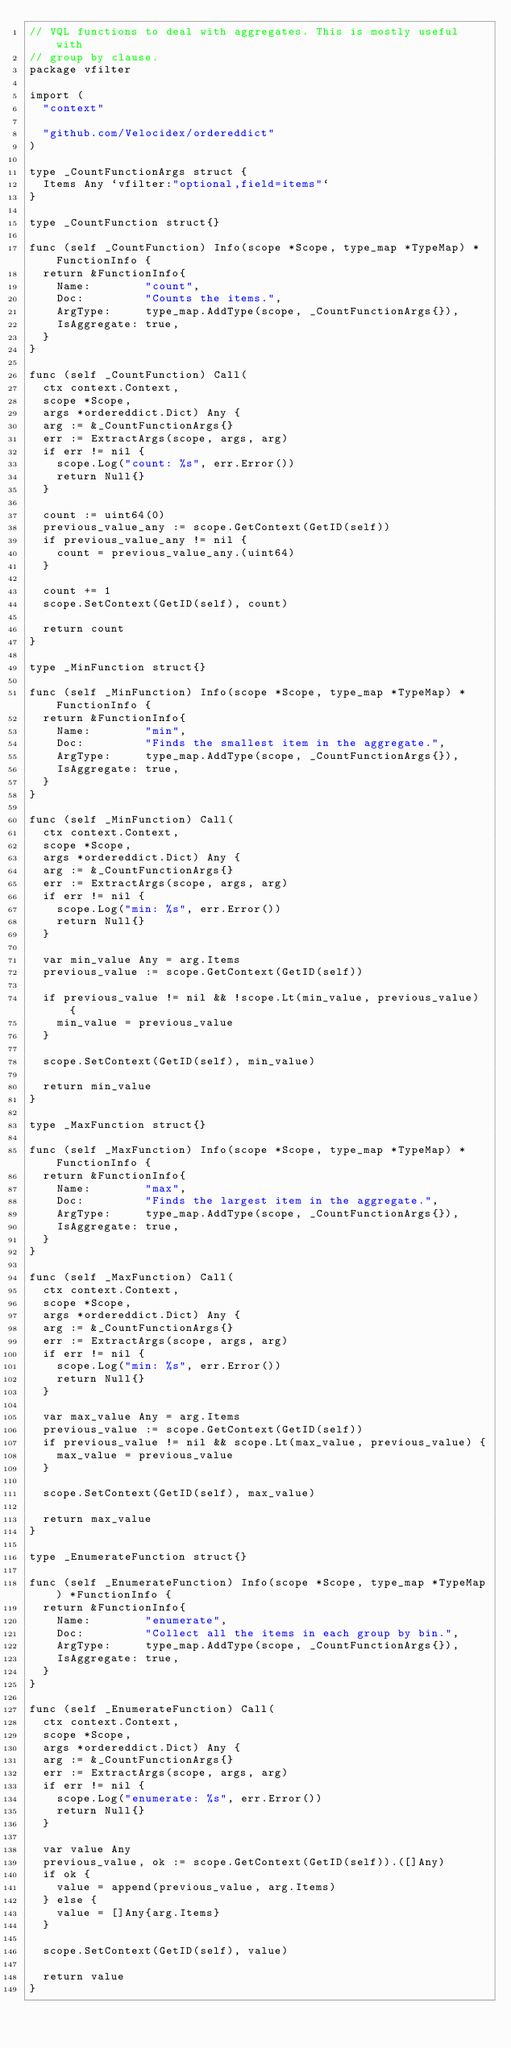Convert code to text. <code><loc_0><loc_0><loc_500><loc_500><_Go_>// VQL functions to deal with aggregates. This is mostly useful with
// group by clause.
package vfilter

import (
	"context"

	"github.com/Velocidex/ordereddict"
)

type _CountFunctionArgs struct {
	Items Any `vfilter:"optional,field=items"`
}

type _CountFunction struct{}

func (self _CountFunction) Info(scope *Scope, type_map *TypeMap) *FunctionInfo {
	return &FunctionInfo{
		Name:        "count",
		Doc:         "Counts the items.",
		ArgType:     type_map.AddType(scope, _CountFunctionArgs{}),
		IsAggregate: true,
	}
}

func (self _CountFunction) Call(
	ctx context.Context,
	scope *Scope,
	args *ordereddict.Dict) Any {
	arg := &_CountFunctionArgs{}
	err := ExtractArgs(scope, args, arg)
	if err != nil {
		scope.Log("count: %s", err.Error())
		return Null{}
	}

	count := uint64(0)
	previous_value_any := scope.GetContext(GetID(self))
	if previous_value_any != nil {
		count = previous_value_any.(uint64)
	}

	count += 1
	scope.SetContext(GetID(self), count)

	return count
}

type _MinFunction struct{}

func (self _MinFunction) Info(scope *Scope, type_map *TypeMap) *FunctionInfo {
	return &FunctionInfo{
		Name:        "min",
		Doc:         "Finds the smallest item in the aggregate.",
		ArgType:     type_map.AddType(scope, _CountFunctionArgs{}),
		IsAggregate: true,
	}
}

func (self _MinFunction) Call(
	ctx context.Context,
	scope *Scope,
	args *ordereddict.Dict) Any {
	arg := &_CountFunctionArgs{}
	err := ExtractArgs(scope, args, arg)
	if err != nil {
		scope.Log("min: %s", err.Error())
		return Null{}
	}

	var min_value Any = arg.Items
	previous_value := scope.GetContext(GetID(self))

	if previous_value != nil && !scope.Lt(min_value, previous_value) {
		min_value = previous_value
	}

	scope.SetContext(GetID(self), min_value)

	return min_value
}

type _MaxFunction struct{}

func (self _MaxFunction) Info(scope *Scope, type_map *TypeMap) *FunctionInfo {
	return &FunctionInfo{
		Name:        "max",
		Doc:         "Finds the largest item in the aggregate.",
		ArgType:     type_map.AddType(scope, _CountFunctionArgs{}),
		IsAggregate: true,
	}
}

func (self _MaxFunction) Call(
	ctx context.Context,
	scope *Scope,
	args *ordereddict.Dict) Any {
	arg := &_CountFunctionArgs{}
	err := ExtractArgs(scope, args, arg)
	if err != nil {
		scope.Log("min: %s", err.Error())
		return Null{}
	}

	var max_value Any = arg.Items
	previous_value := scope.GetContext(GetID(self))
	if previous_value != nil && scope.Lt(max_value, previous_value) {
		max_value = previous_value
	}

	scope.SetContext(GetID(self), max_value)

	return max_value
}

type _EnumerateFunction struct{}

func (self _EnumerateFunction) Info(scope *Scope, type_map *TypeMap) *FunctionInfo {
	return &FunctionInfo{
		Name:        "enumerate",
		Doc:         "Collect all the items in each group by bin.",
		ArgType:     type_map.AddType(scope, _CountFunctionArgs{}),
		IsAggregate: true,
	}
}

func (self _EnumerateFunction) Call(
	ctx context.Context,
	scope *Scope,
	args *ordereddict.Dict) Any {
	arg := &_CountFunctionArgs{}
	err := ExtractArgs(scope, args, arg)
	if err != nil {
		scope.Log("enumerate: %s", err.Error())
		return Null{}
	}

	var value Any
	previous_value, ok := scope.GetContext(GetID(self)).([]Any)
	if ok {
		value = append(previous_value, arg.Items)
	} else {
		value = []Any{arg.Items}
	}

	scope.SetContext(GetID(self), value)

	return value
}
</code> 